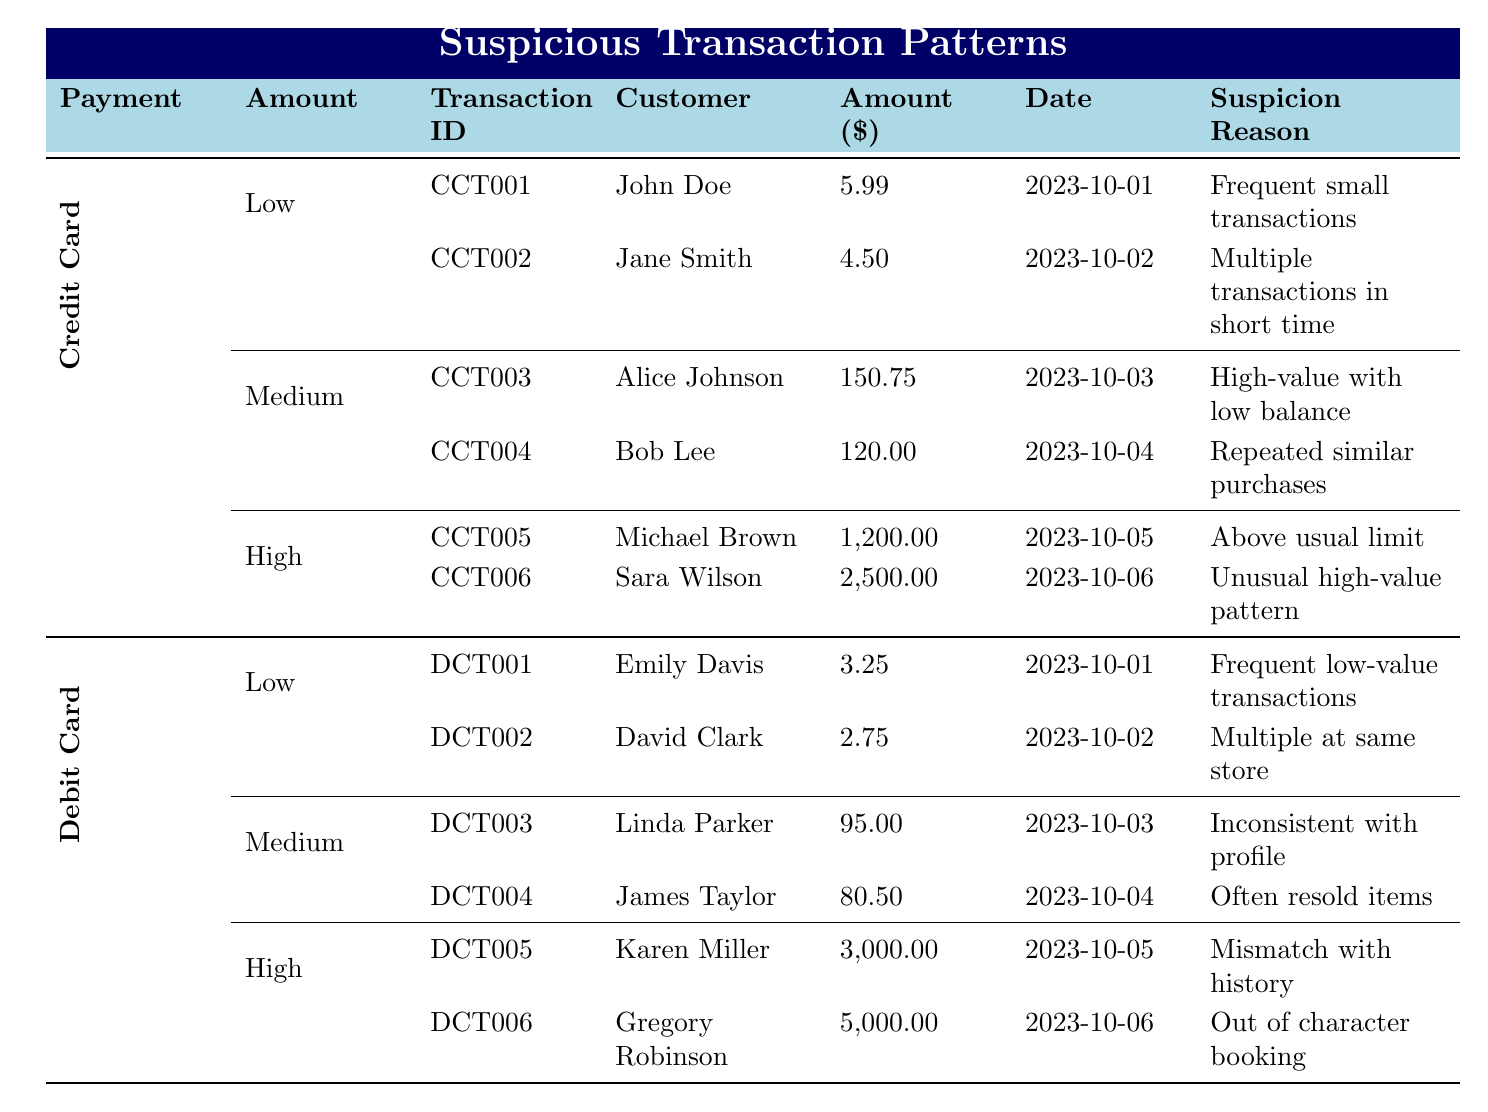What is the transaction ID for the low amount suspicious transaction made by John Doe? The table lists the details for low amount suspicious transactions under credit card. John Doe made a transaction identified as CCT001.
Answer: CCT001 How many high amount transactions are recorded for debit cards? The table shows that there are two high amount transactions under debit cards: DCT005 and DCT006.
Answer: 2 What is the total amount of medium level suspicious transactions for credit cards? The medium amount transactions for credit cards are CCT003 (150.75) and CCT004 (120.00). Adding these amounts gives 150.75 + 120.00 = 270.75.
Answer: 270.75 Is there a suspicious transaction associated with the merchant "Jewelry Store"? The table indicates that Sara Wilson made a high amount transaction for $2500.00 at the Jewelry Store, classified as suspicious.
Answer: Yes Which customer has the highest amount transaction for a debit card and what was the amount? The highest transaction amount for a debit card is associated with Gregory Robinson, with a transaction amount of $5000.00 on 2023-10-06.
Answer: Gregory Robinson, $5000.00 What is the average amount of low level suspicious transactions across both payment methods? For low amount transactions, we have CCT001 (5.99), CCT002 (4.50), DCT001 (3.25), and DCT002 (2.75). Summing these gives 5.99 + 4.50 + 3.25 + 2.75 = 16.49. Dividing this by 4 gives an average of 4.1225.
Answer: 4.12 Are there more suspicious transactions in the medium amount category for credit cards or debit cards? The table shows 2 medium amount transactions for credit cards (CCT003 and CCT004) and 2 for debit cards (DCT003 and DCT004). Since the number is equal, neither category has more transactions.
Answer: Neither What is the suspicion reason for the transaction made by Alice Johnson? The table indicates that Alice Johnson's medium amount transaction (CCT003) had a suspicion reason of "High-value purchase with low account balance."
Answer: High-value purchase with low account balance 